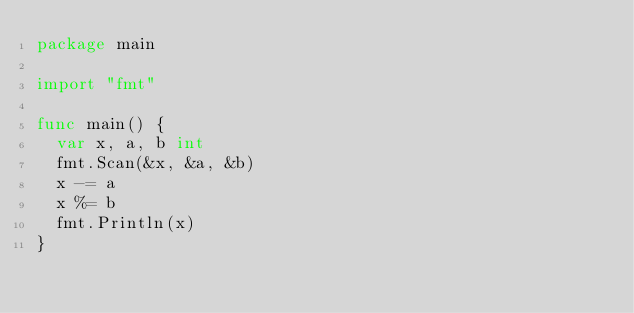<code> <loc_0><loc_0><loc_500><loc_500><_Go_>package main

import "fmt"

func main() {
	var x, a, b int
	fmt.Scan(&x, &a, &b)
	x -= a
	x %= b
	fmt.Println(x)
}
</code> 